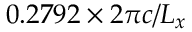<formula> <loc_0><loc_0><loc_500><loc_500>0 . 2 7 9 2 \times 2 \pi c / L _ { x }</formula> 